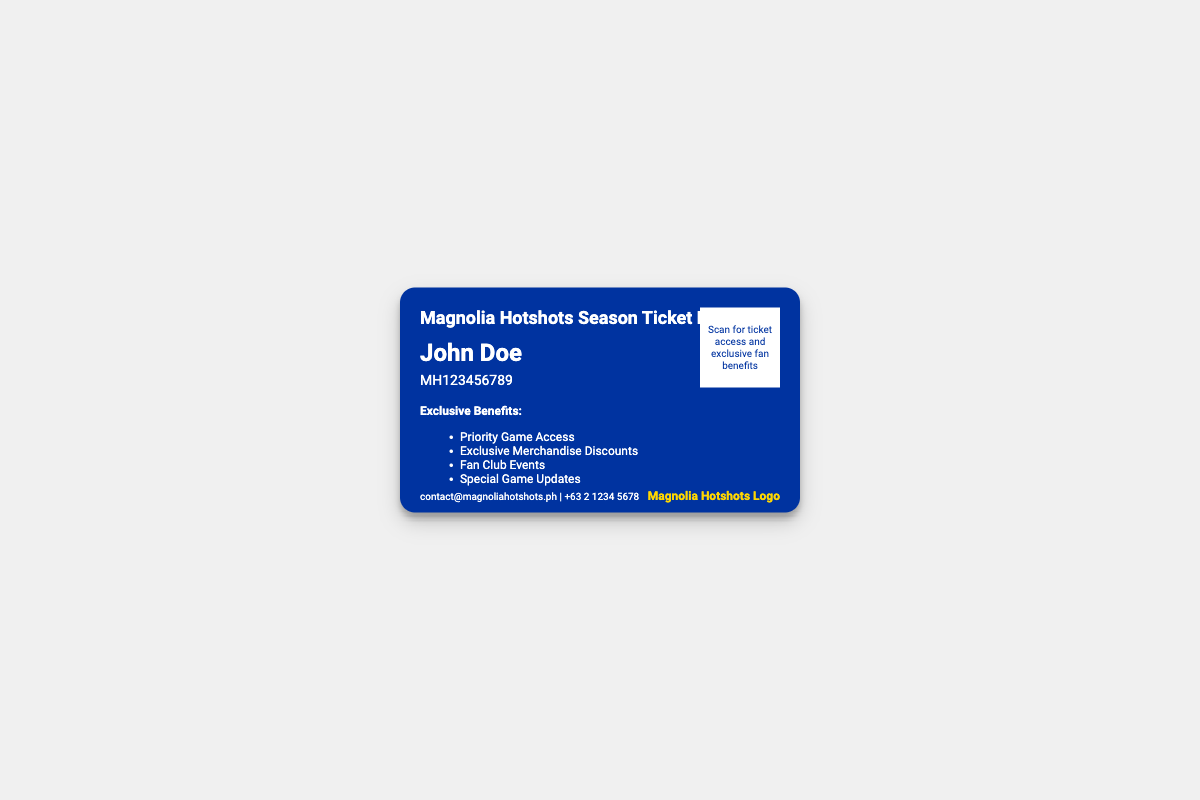What is the cardholder's name? The cardholder's name is displayed prominently in the document.
Answer: John Doe What is the membership ID? The membership ID can be found below the cardholder's name.
Answer: MH123456789 What is one of the exclusive benefits? The document lists several benefits that can be referenced.
Answer: Priority Game Access What is the contact email? The contact information is listed at the bottom of the card, including an email.
Answer: contact@magnoliahotshots.ph What color is the card's background? The background color of the card is specified in the design.
Answer: #0033A0 How many exclusive benefits are listed? The document enumerates the exclusive benefits provided to the cardholder.
Answer: Four What does the QR code provide access to? The function of the QR code is stated within its description.
Answer: Ticket access and exclusive fan benefits What is the font used for the card? The font type is mentioned in the CSS of the document.
Answer: Roboto What is the logo's color? The color of the logo is indicated in the design details.
Answer: Gold 